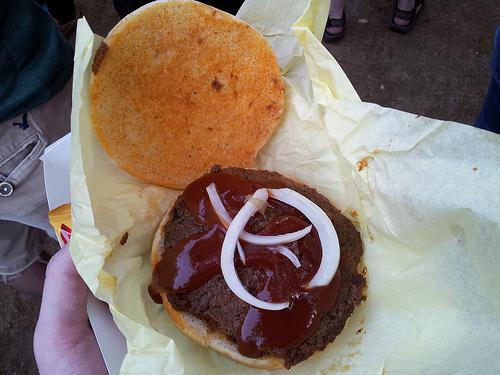Question: how many faces are in the photo?
Choices:
A. 0.
B. 1.
C. 2.
D. 3.
Answer with the letter. Answer: A Question: what toppings are on the burger?
Choices:
A. Barbecue sauce and onions.
B. Ketchup.
C. Mustard.
D. Lettuce.
Answer with the letter. Answer: A Question: who is wearing sandals?
Choices:
A. The person in the background.
B. The father.
C. Everyone.
D. The photographer.
Answer with the letter. Answer: A 